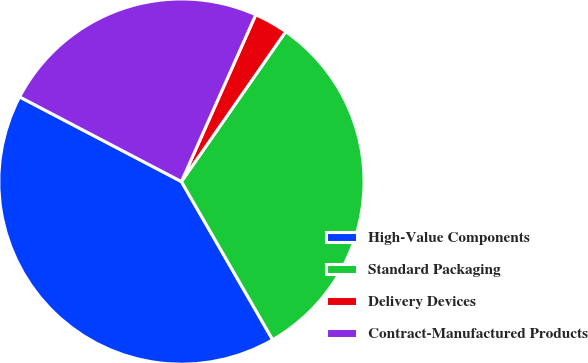<chart> <loc_0><loc_0><loc_500><loc_500><pie_chart><fcel>High-Value Components<fcel>Standard Packaging<fcel>Delivery Devices<fcel>Contract-Manufactured Products<nl><fcel>41.0%<fcel>32.0%<fcel>3.0%<fcel>24.0%<nl></chart> 